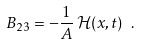Convert formula to latex. <formula><loc_0><loc_0><loc_500><loc_500>B _ { 2 3 } = - \frac { 1 } { A } \, \mathcal { H } ( x , t ) \ .</formula> 